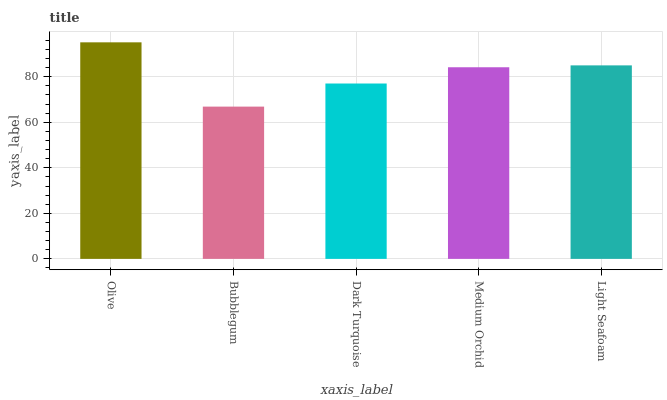Is Bubblegum the minimum?
Answer yes or no. Yes. Is Olive the maximum?
Answer yes or no. Yes. Is Dark Turquoise the minimum?
Answer yes or no. No. Is Dark Turquoise the maximum?
Answer yes or no. No. Is Dark Turquoise greater than Bubblegum?
Answer yes or no. Yes. Is Bubblegum less than Dark Turquoise?
Answer yes or no. Yes. Is Bubblegum greater than Dark Turquoise?
Answer yes or no. No. Is Dark Turquoise less than Bubblegum?
Answer yes or no. No. Is Medium Orchid the high median?
Answer yes or no. Yes. Is Medium Orchid the low median?
Answer yes or no. Yes. Is Bubblegum the high median?
Answer yes or no. No. Is Light Seafoam the low median?
Answer yes or no. No. 